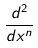<formula> <loc_0><loc_0><loc_500><loc_500>\frac { d ^ { 2 } } { d x ^ { n } }</formula> 